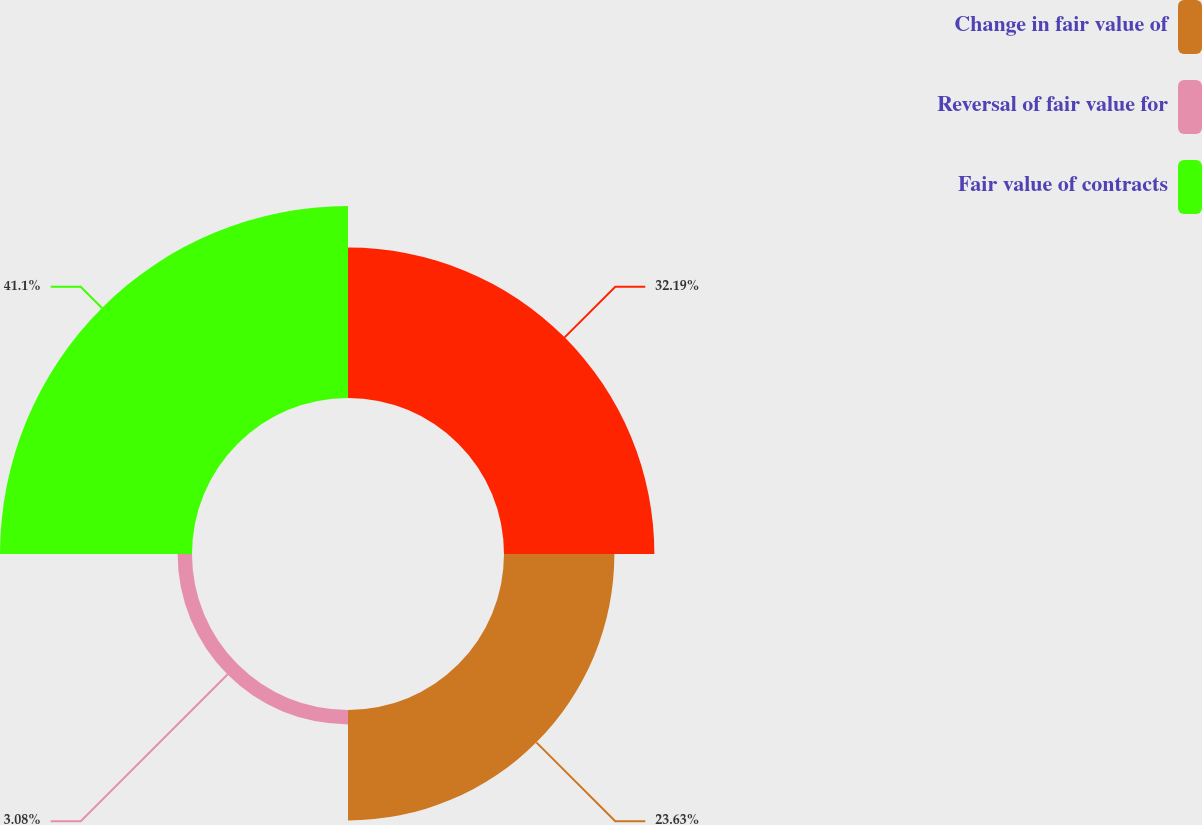Convert chart. <chart><loc_0><loc_0><loc_500><loc_500><pie_chart><ecel><fcel>Change in fair value of<fcel>Reversal of fair value for<fcel>Fair value of contracts<nl><fcel>32.19%<fcel>23.63%<fcel>3.08%<fcel>41.1%<nl></chart> 